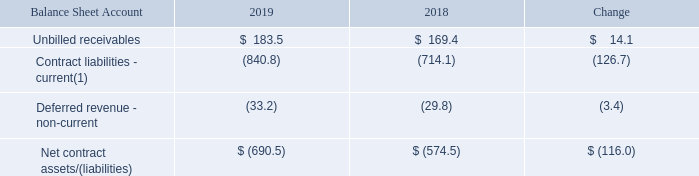(15) CONTRACT BALANCES
Contract balances at December 31 are set forth in the following table:
The change in our net contract assets/(liabilities) from December 31, 2018 to December 31, 2019 was due primarily to the timing of payments and invoicing relating to SaaS and PCS renewals, partially offset by revenues recognized in the year ended December 31, 2019 of $674.2, related to our contract liability balances at December 31, 2018. In addition, the impact of the 2019 business acquisitions increased net contract liabilities by $96.2.
In order to determine revenues recognized in the period from contract liabilities, we allocate revenue to the individual deferred revenue or BIE balance outstanding at the beginning of the year until the revenue exceeds that balance.
Impairment losses recognized on our accounts receivable and unbilled receivables were immaterial in the year ended December 31, 2019.
(1) Consists of “Deferred revenue,” and billings in-excess of revenues (“BIE”). BIE are reported in “Other accrued liabilities” in our Consolidated Balance Sheets.
How does the Company determine revenues recognized in the period from contract liabilities? We allocate revenue to the individual deferred revenue or bie balance outstanding at the beginning of the year until the revenue exceeds that balance. What were immaterial on the Company’s accounts receivable and unbilled receivables?  Impairment losses. How much were the net contract assets/(liabilities), in 2019? $ (690.5). What are the average unbilled receivables from 2018 to 2019?
Answer scale should be: million. (183.5+169.4)/2 
Answer: 176.45. What is the ratio of unbilled receivables to revenues in year ended December 31,2019? 183.5/674.2 
Answer: 0.27. What is the percentage change in current contract liabilities in 2019 compared to 2018?
Answer scale should be: percent. -126.7/-714.1 
Answer: 17.74. 